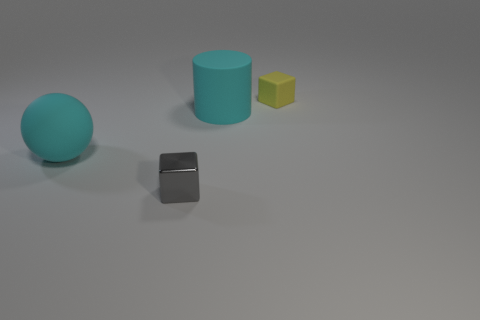There is a big thing that is the same color as the cylinder; what is it made of?
Keep it short and to the point. Rubber. There is a tiny thing that is behind the large cyan object that is left of the cube to the left of the tiny yellow block; what is its color?
Provide a succinct answer. Yellow. What is the shape of the big matte object behind the big rubber sphere?
Provide a short and direct response. Cylinder. There is a small thing that is the same material as the large cyan sphere; what shape is it?
Give a very brief answer. Cube. Is there anything else that has the same shape as the yellow thing?
Offer a very short reply. Yes. There is a yellow matte cube; what number of gray shiny objects are to the left of it?
Your answer should be very brief. 1. Are there the same number of tiny yellow matte blocks that are in front of the large matte sphere and green rubber spheres?
Your answer should be very brief. Yes. Do the cyan ball and the yellow cube have the same material?
Ensure brevity in your answer.  Yes. There is a matte object that is on the right side of the large cyan ball and in front of the rubber cube; what size is it?
Offer a very short reply. Large. What number of other yellow blocks have the same size as the yellow cube?
Give a very brief answer. 0. 